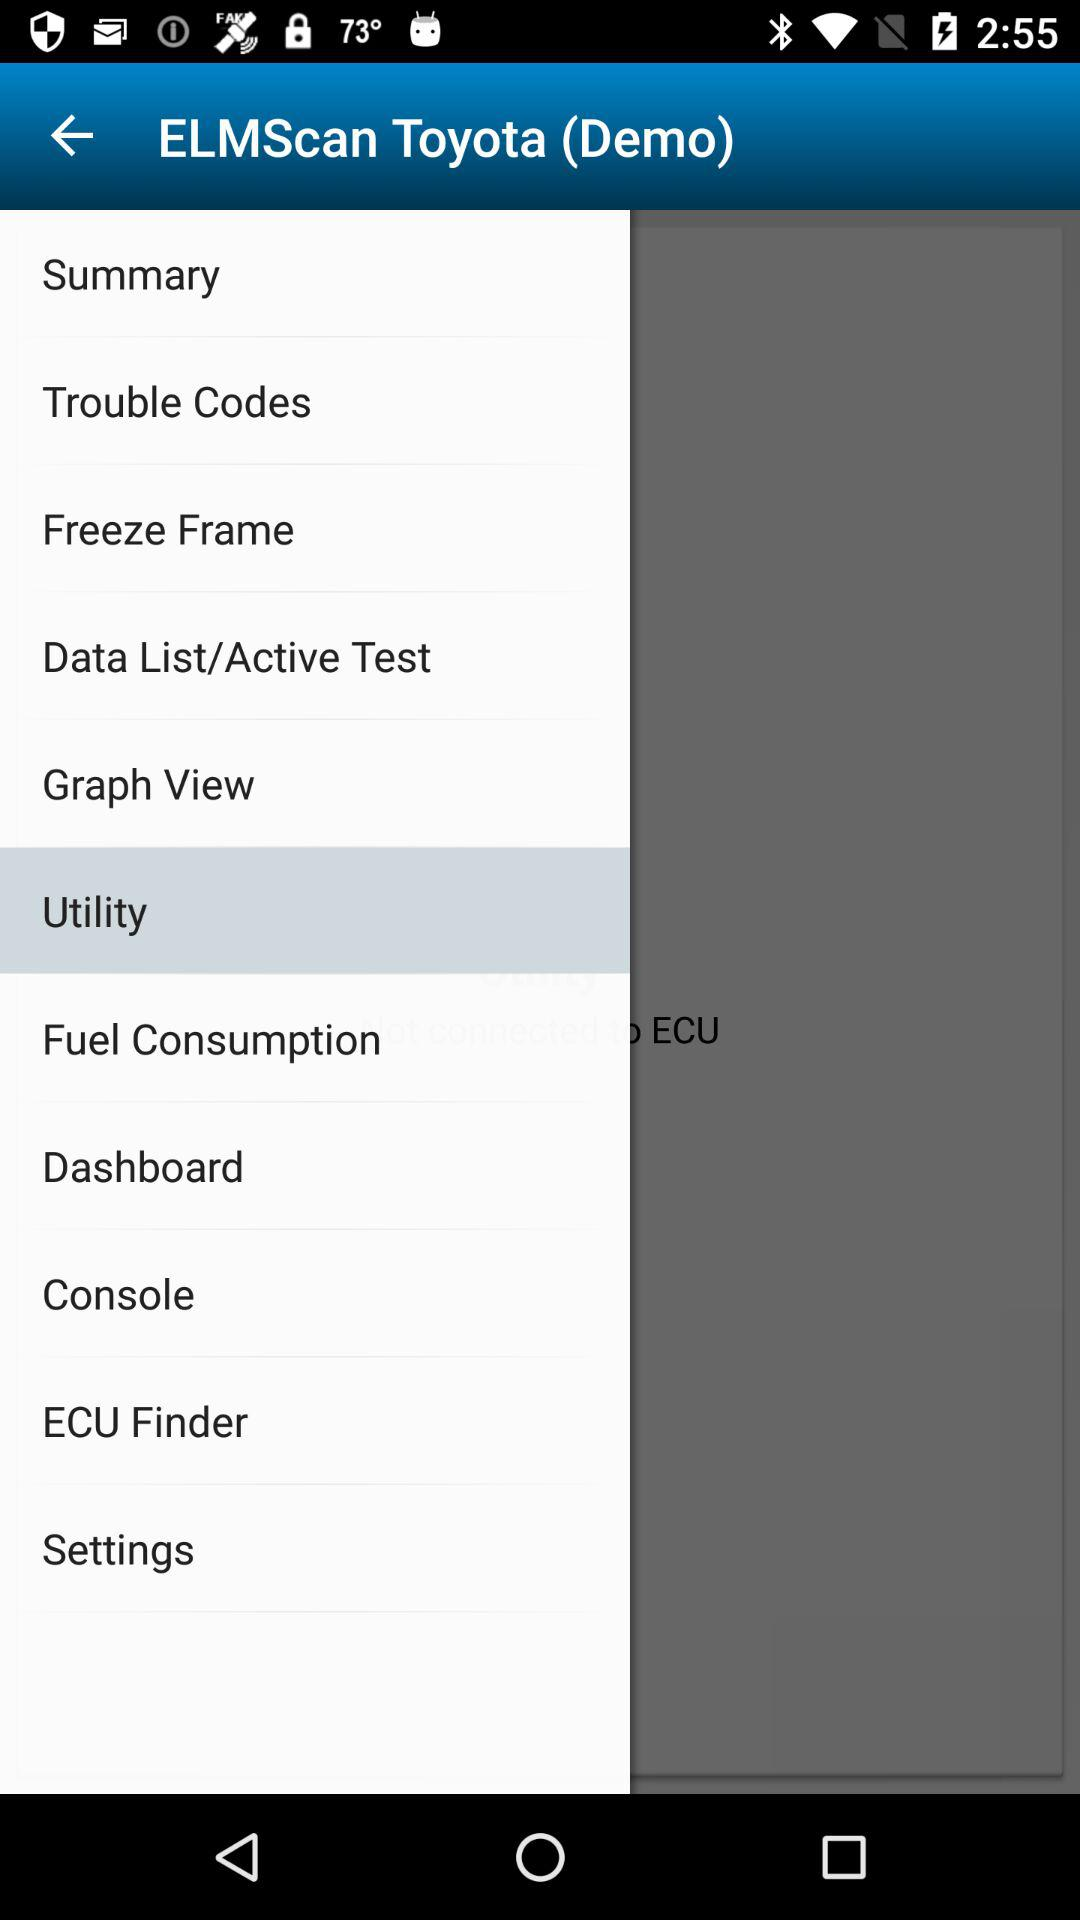Which item is selected in "ELMScan Toyota"? The selected item is "Utility". 